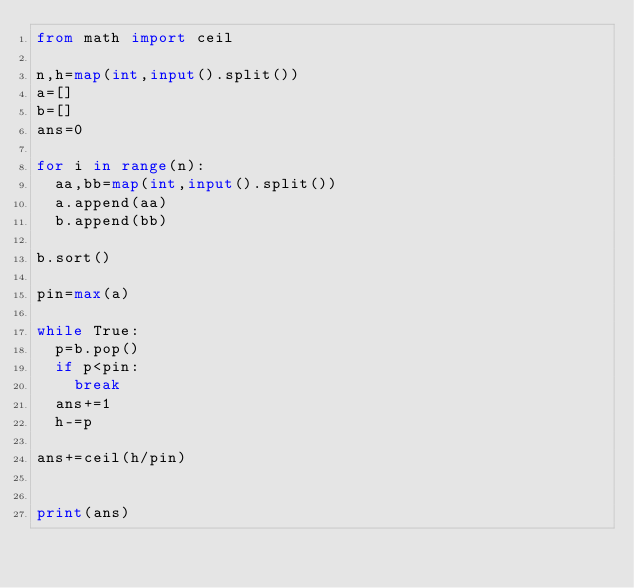Convert code to text. <code><loc_0><loc_0><loc_500><loc_500><_Python_>from math import ceil

n,h=map(int,input().split())
a=[]
b=[]
ans=0

for i in range(n):
  aa,bb=map(int,input().split())
  a.append(aa)
  b.append(bb)

b.sort()

pin=max(a)

while True:
  p=b.pop()
  if p<pin:
    break
  ans+=1
  h-=p

ans+=ceil(h/pin)


print(ans)</code> 